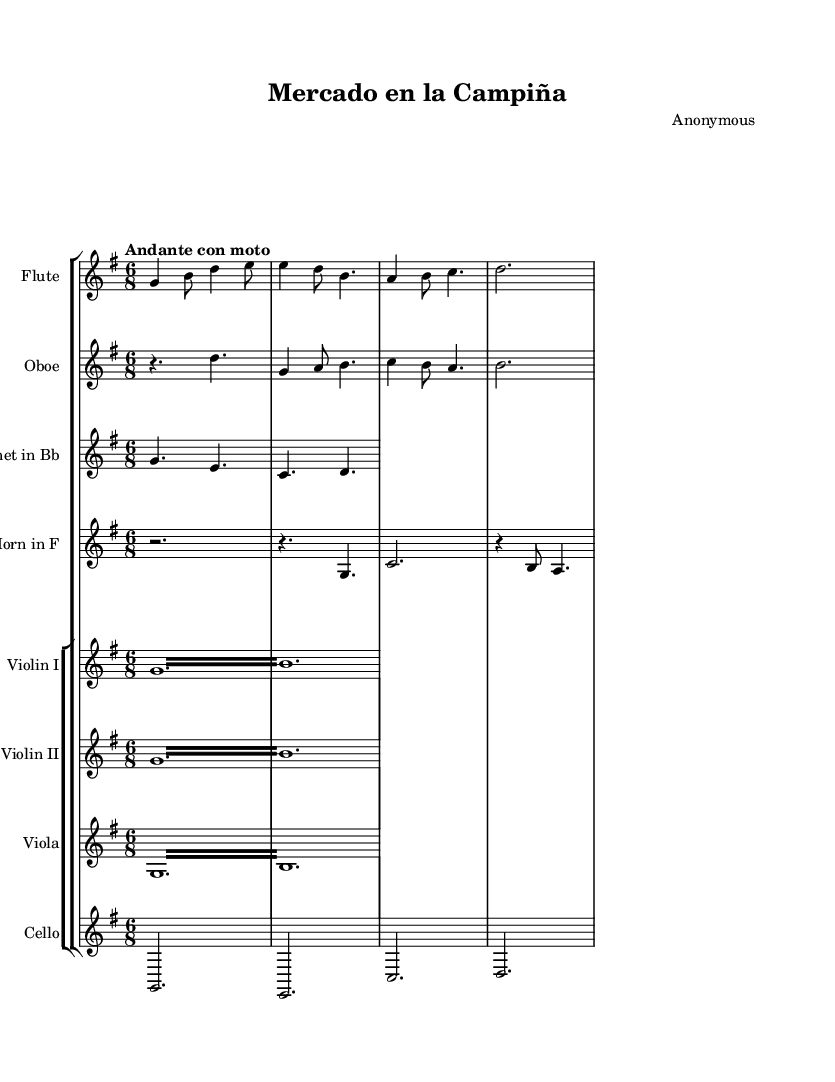What is the key signature of this music? The key signature is G major, which has one sharp (F#). You can identify the key signature from the beginning of the staff, where it shows one sharp on the top line of the treble clef.
Answer: G major What is the time signature of this music? The time signature is 6/8. This can be found at the beginning of the score, indicated by the two numbers stacked vertically. The upper number (6) represents the number of beats in each measure, and the lower number (8) indicates that the eighth note gets one beat.
Answer: 6/8 What is the tempo marking of this symphony? The tempo marking is "Andante con moto." It is noted at the beginning of the score, which gives performers an indication of the speed and character of the piece. "Andante" suggests a moderate tempo, while "con moto" indicates a little movement, suggesting a slightly faster pace than typical andante.
Answer: Andante con moto How many instruments are featured in this symphony? There are seven instruments featured in the symphony. This can be determined by counting each staff labeled with different instruments in the score, including flute, oboe, clarinet, horn, violin I, violin II, viola, and cello.
Answer: Seven What is the texture of the string instruments in this piece? The texture of the string instruments is tremolo. This can be identified in the parts for Violin I, Violin II, and Viola where "tremolo" is notated. This indicates that the performers should play rapid repetitions of the same pitch, creating a shimmering effect.
Answer: Tremolo Which woodwind instrument has a rest at the beginning? The oboe has a rest at the beginning. You can see this by looking at the oboe staff, where there is a rest symbol before any notes are played, indicating that the oboe does not sound at the start of the piece.
Answer: Oboe 